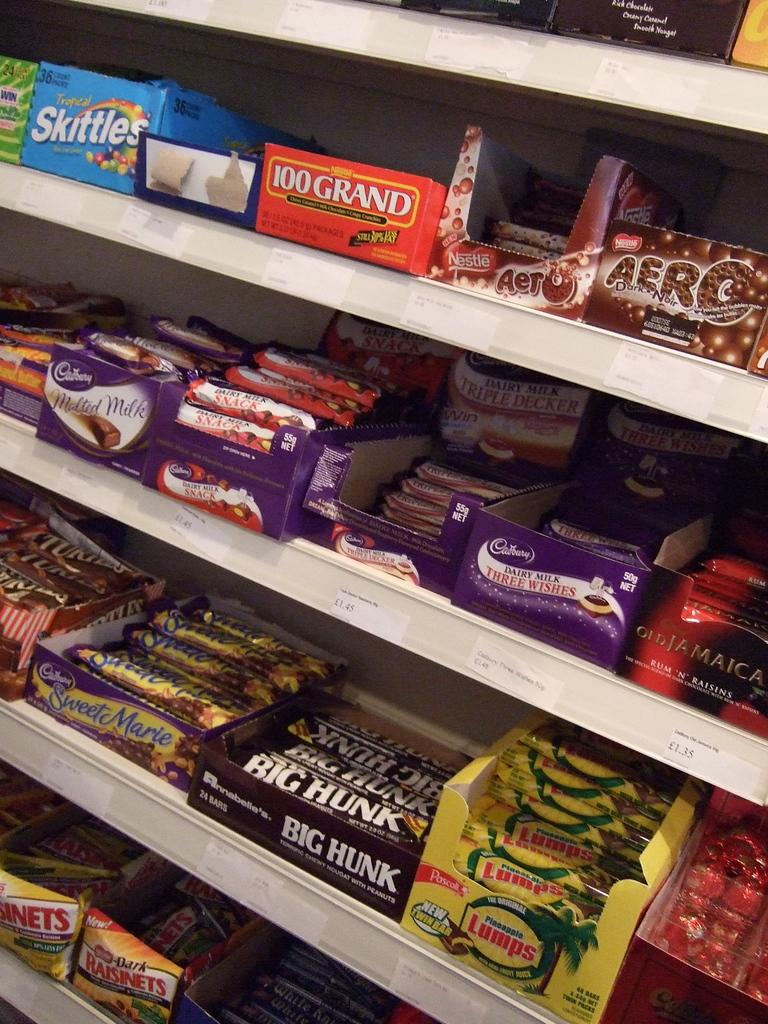<image>
Write a terse but informative summary of the picture. candy isle with boxes of skittles, 100 grand, raisinets, and others 